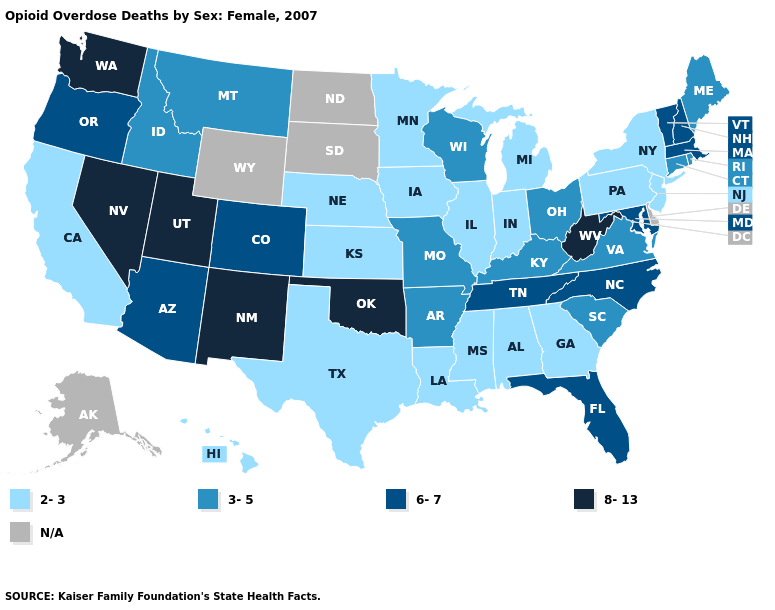Which states have the highest value in the USA?
Be succinct. Nevada, New Mexico, Oklahoma, Utah, Washington, West Virginia. Name the states that have a value in the range 3-5?
Give a very brief answer. Arkansas, Connecticut, Idaho, Kentucky, Maine, Missouri, Montana, Ohio, Rhode Island, South Carolina, Virginia, Wisconsin. Does Washington have the lowest value in the USA?
Give a very brief answer. No. What is the value of Connecticut?
Answer briefly. 3-5. Name the states that have a value in the range 2-3?
Concise answer only. Alabama, California, Georgia, Hawaii, Illinois, Indiana, Iowa, Kansas, Louisiana, Michigan, Minnesota, Mississippi, Nebraska, New Jersey, New York, Pennsylvania, Texas. Does Nevada have the lowest value in the West?
Be succinct. No. Among the states that border Illinois , which have the lowest value?
Write a very short answer. Indiana, Iowa. What is the value of Oregon?
Quick response, please. 6-7. Does Nevada have the highest value in the USA?
Concise answer only. Yes. What is the value of North Carolina?
Quick response, please. 6-7. Name the states that have a value in the range 6-7?
Answer briefly. Arizona, Colorado, Florida, Maryland, Massachusetts, New Hampshire, North Carolina, Oregon, Tennessee, Vermont. Name the states that have a value in the range 2-3?
Be succinct. Alabama, California, Georgia, Hawaii, Illinois, Indiana, Iowa, Kansas, Louisiana, Michigan, Minnesota, Mississippi, Nebraska, New Jersey, New York, Pennsylvania, Texas. What is the value of Alabama?
Answer briefly. 2-3. 